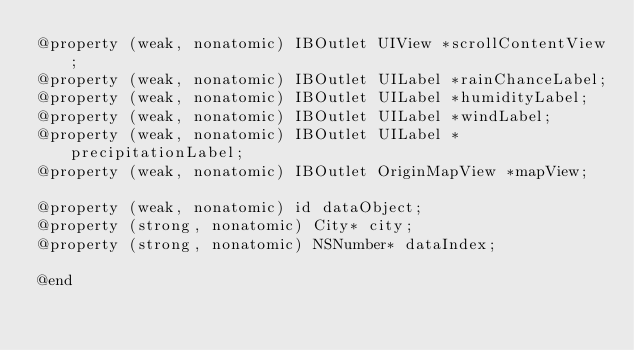Convert code to text. <code><loc_0><loc_0><loc_500><loc_500><_C_>@property (weak, nonatomic) IBOutlet UIView *scrollContentView;
@property (weak, nonatomic) IBOutlet UILabel *rainChanceLabel;
@property (weak, nonatomic) IBOutlet UILabel *humidityLabel;
@property (weak, nonatomic) IBOutlet UILabel *windLabel;
@property (weak, nonatomic) IBOutlet UILabel *precipitationLabel;
@property (weak, nonatomic) IBOutlet OriginMapView *mapView;

@property (weak, nonatomic) id dataObject;
@property (strong, nonatomic) City* city;
@property (strong, nonatomic) NSNumber* dataIndex;

@end

</code> 